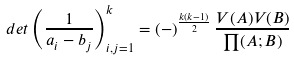Convert formula to latex. <formula><loc_0><loc_0><loc_500><loc_500>d e t \left ( \frac { 1 } { a _ { i } - b _ { j } } \right ) _ { i , j = 1 } ^ { k } = ( - ) ^ { \frac { k ( k - 1 ) } { 2 } } \, \frac { V ( A ) V ( B ) } { \prod ( A ; B ) }</formula> 